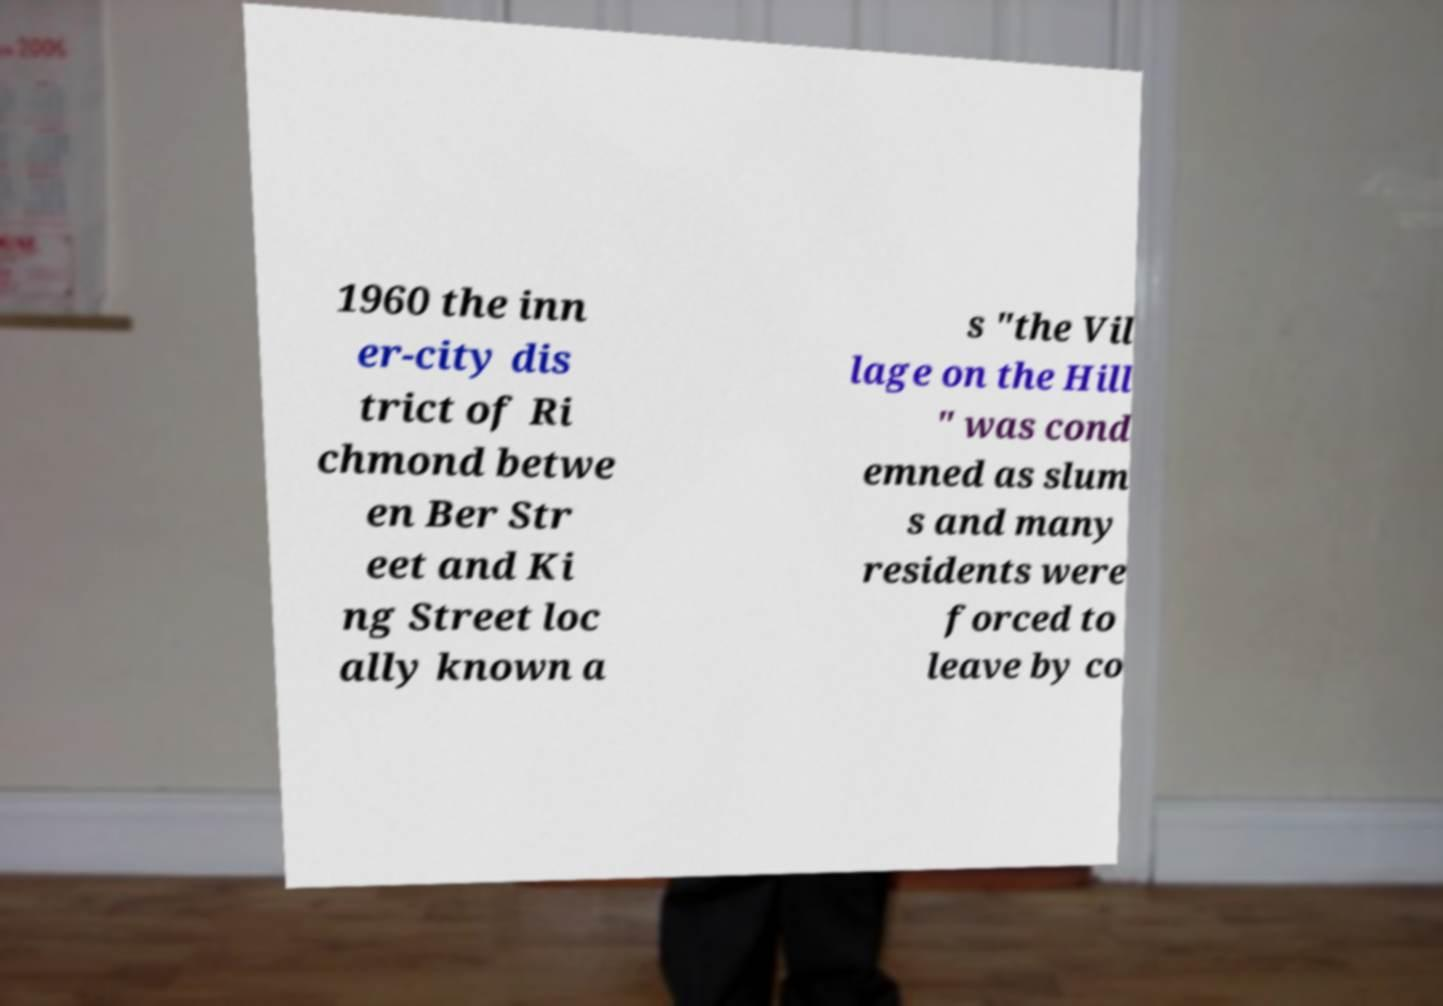Can you accurately transcribe the text from the provided image for me? 1960 the inn er-city dis trict of Ri chmond betwe en Ber Str eet and Ki ng Street loc ally known a s "the Vil lage on the Hill " was cond emned as slum s and many residents were forced to leave by co 